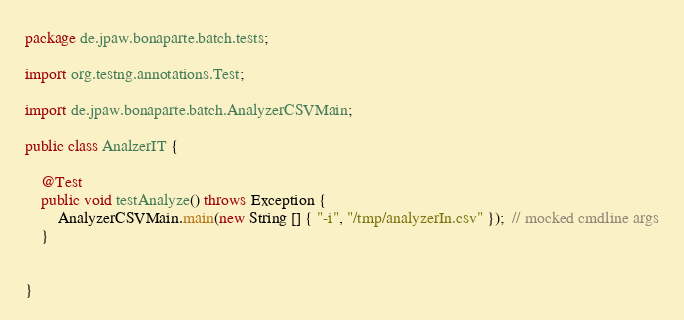Convert code to text. <code><loc_0><loc_0><loc_500><loc_500><_Java_>package de.jpaw.bonaparte.batch.tests;

import org.testng.annotations.Test;

import de.jpaw.bonaparte.batch.AnalyzerCSVMain;

public class AnalzerIT {

    @Test
    public void testAnalyze() throws Exception {
        AnalyzerCSVMain.main(new String [] { "-i", "/tmp/analyzerIn.csv" });  // mocked cmdline args
    }


}
</code> 